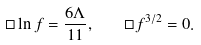Convert formula to latex. <formula><loc_0><loc_0><loc_500><loc_500>\Box \ln f = \frac { 6 \Lambda } { 1 1 } , \quad \Box f ^ { 3 / 2 } = 0 .</formula> 